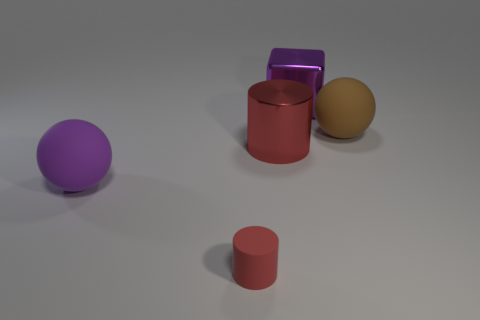Are there any other things that are the same size as the red rubber object?
Give a very brief answer. No. There is a sphere behind the red metal object that is on the right side of the purple matte ball; how many large things are in front of it?
Provide a short and direct response. 2. Are there fewer objects on the left side of the metallic cube than objects?
Make the answer very short. Yes. Do the tiny cylinder and the large cylinder have the same color?
Your answer should be compact. Yes. There is another thing that is the same shape as the red metallic object; what size is it?
Provide a short and direct response. Small. What number of other cylinders are the same material as the tiny cylinder?
Your answer should be compact. 0. Does the large ball that is on the left side of the brown matte sphere have the same material as the large red thing?
Your response must be concise. No. Are there the same number of matte objects that are behind the big red shiny cylinder and small metallic balls?
Offer a terse response. No. What is the size of the metallic block?
Your answer should be very brief. Large. There is a thing that is the same color as the small rubber cylinder; what material is it?
Provide a short and direct response. Metal. 